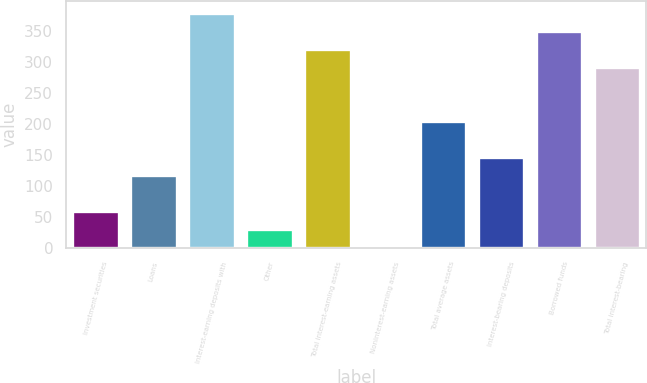Convert chart to OTSL. <chart><loc_0><loc_0><loc_500><loc_500><bar_chart><fcel>Investment securities<fcel>Loans<fcel>Interest-earning deposits with<fcel>Other<fcel>Total interest-earning assets<fcel>Noninterest-earning assets<fcel>Total average assets<fcel>Interest-bearing deposits<fcel>Borrowed funds<fcel>Total interest-bearing<nl><fcel>59<fcel>117<fcel>378<fcel>30<fcel>320<fcel>1<fcel>204<fcel>146<fcel>349<fcel>291<nl></chart> 